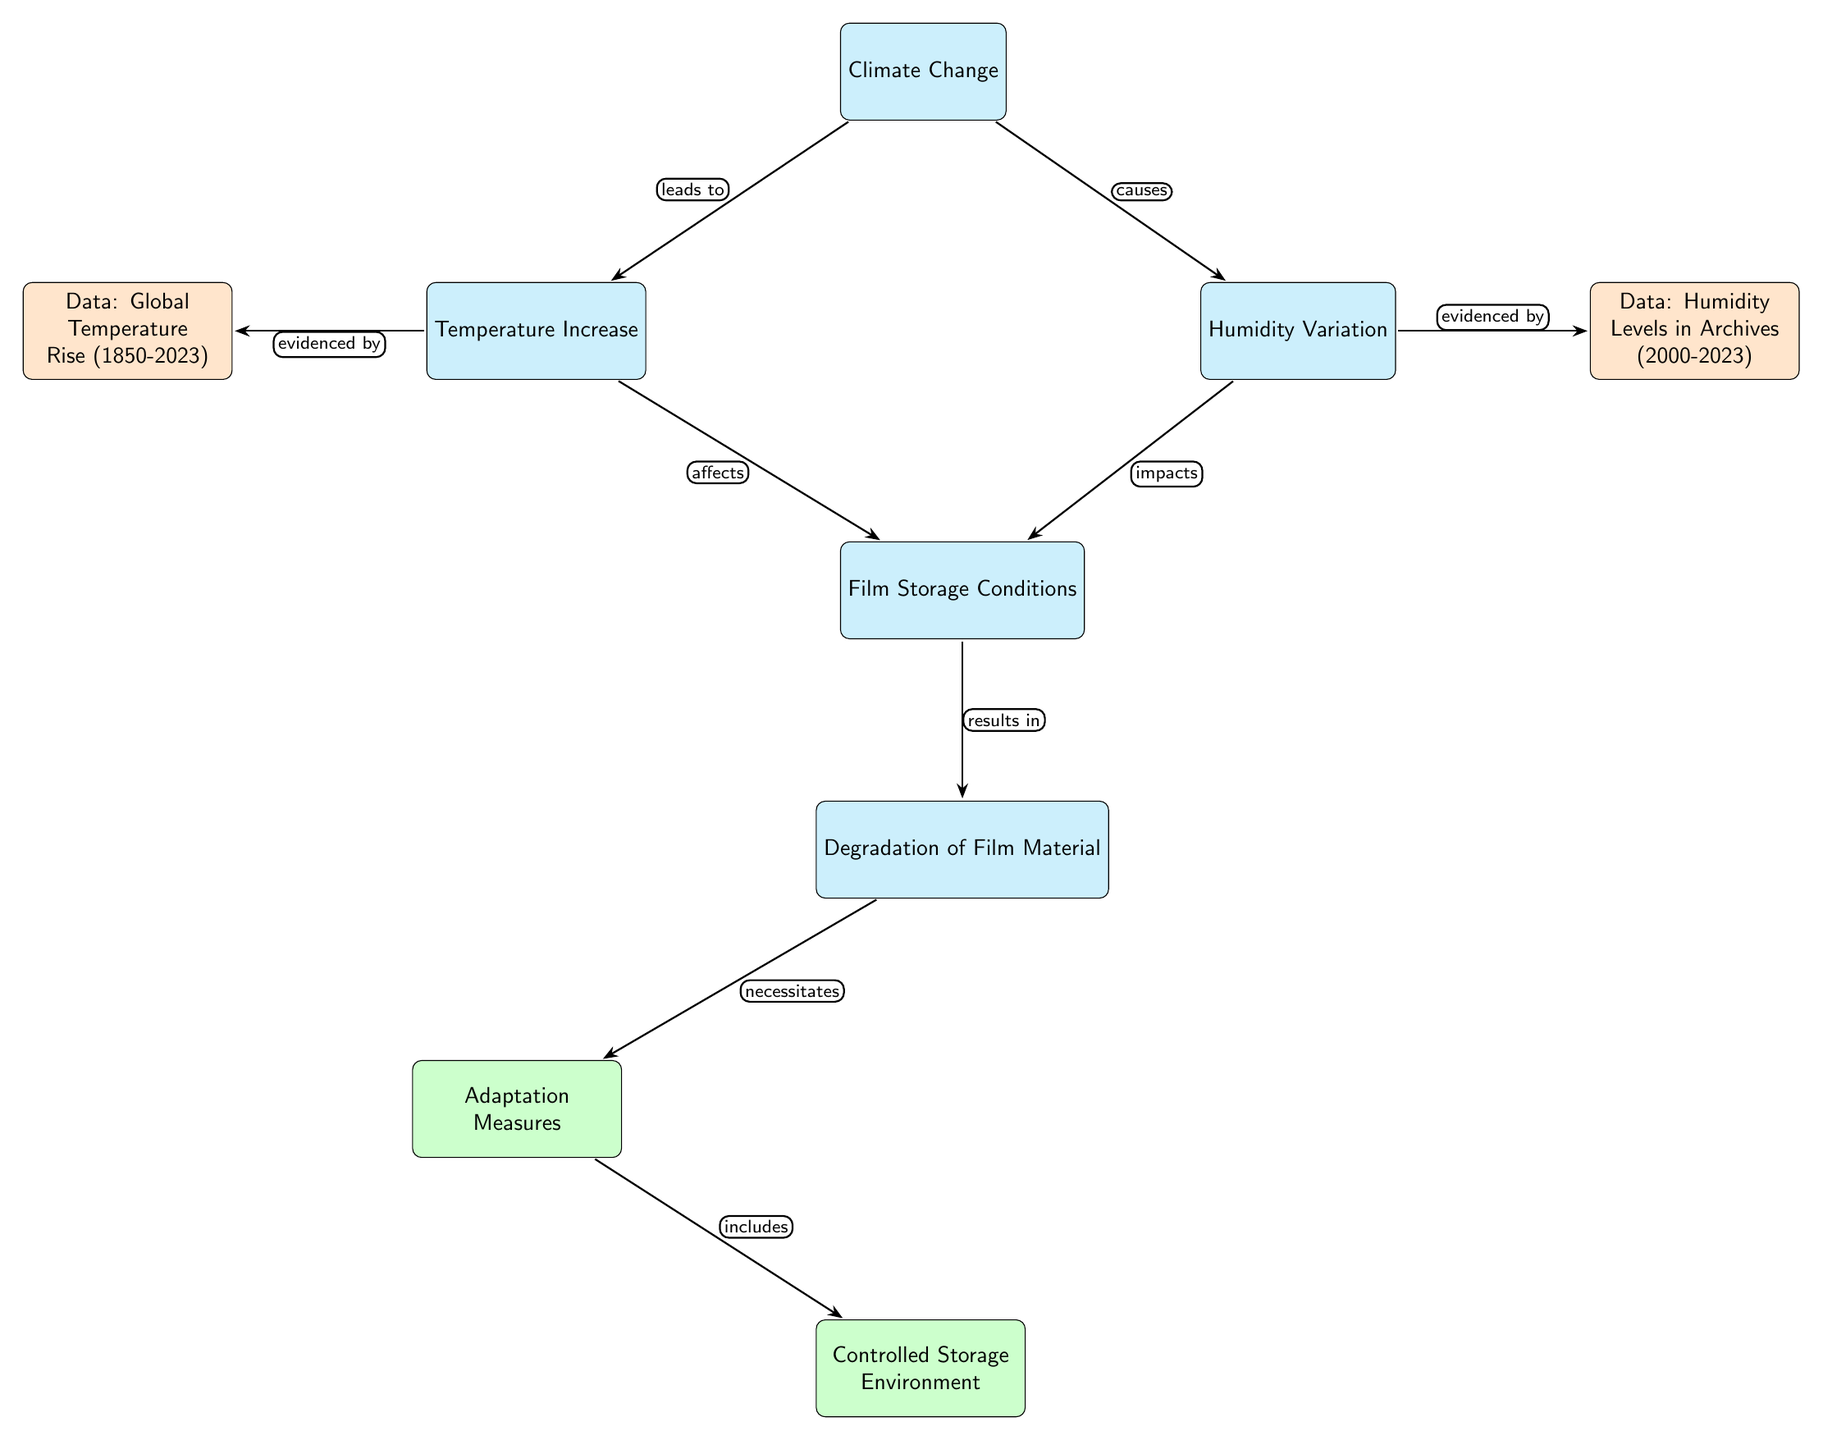What is the first node in the diagram? The diagram starts with the node labeled "Climate Change," which is positioned at the top.
Answer: Climate Change How many main nodes are there in total? There are five main nodes in the diagram, which include "Climate Change," "Temperature Increase," "Humidity Variation," "Film Storage Conditions," and "Degradation of Film Material."
Answer: 5 What does "Temperature Increase" lead to? The "Temperature Increase" node is connected to the "Film Storage Conditions" node through an arrow that indicates it affects those conditions.
Answer: Film Storage Conditions What do the arrows signify in this diagram? The arrows in the diagram denote a variety of relationships, such as causes, leads to, impacts, and results in, indicating how the nodes are interconnected.
Answer: Relationships Which node evidences "Global Temperature Rise (1850-2023)"? The "Temperature Increase" node is linked to the data node labeled "Data: Global Temperature Rise (1850-2023)."
Answer: Temperature Increase What relationship shows the result of "Humidity Variation"? "Humidity Variation" impacts "Film Storage Conditions," suggesting that changes in humidity directly influence storage conditions.
Answer: impacts Which adaptation measure follows after degradation of film material? "Degradation of Film Material" necessitates "Adaptation Measures," indicating that degradation leads to the need for adapting storage practices.
Answer: Adaptation Measures What type of storage environment is mentioned under adaptation measures? The diagram notes "Controlled Storage Environment" as part of the adaptation measures, suggesting a specific strategy to manage film storage.
Answer: Controlled Storage Environment How does "Climate Change" relate to "Degradation of Film Material"? "Climate Change" indirectly influences "Degradation of Film Material" through both "Temperature Increase" and "Humidity Variation," which affect the film storage conditions that ultimately lead to degradation.
Answer: indirectly influences 